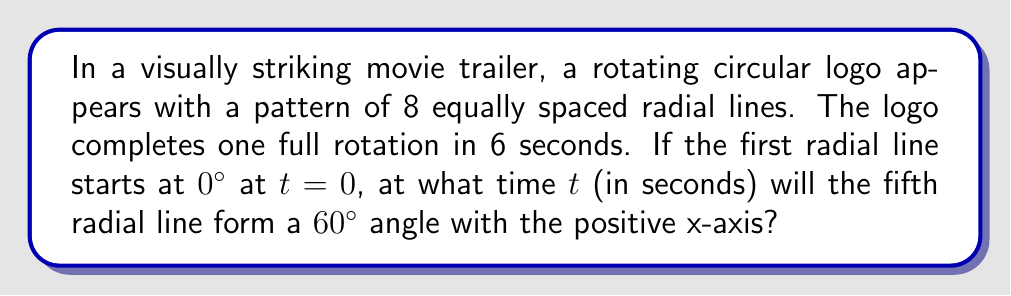Teach me how to tackle this problem. Let's approach this step-by-step:

1) First, we need to understand the angular velocity of the logo:
   $$\omega = \frac{2\pi \text{ radians}}{6 \text{ seconds}} = \frac{\pi}{3} \text{ rad/s}$$

2) The angle between each radial line is:
   $$\theta = \frac{360°}{8} = 45°$$

3) The fifth radial line starts at an angle of:
   $$4 \times 45° = 180°$$

4) We want to find when this line reaches 60°. The total rotation needed is:
   $$60° - 180° = -120° = 240°$$ (in positive direction)

5) Convert 240° to radians:
   $$240° \times \frac{\pi}{180°} = \frac{4\pi}{3} \text{ radians}$$

6) Now we can use the angular velocity equation:
   $$\theta = \omega t$$
   $$\frac{4\pi}{3} = \frac{\pi}{3}t$$

7) Solve for t:
   $$t = \frac{4\pi}{3} \div \frac{\pi}{3} = 4 \text{ seconds}$$
Answer: 4 seconds 